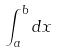Convert formula to latex. <formula><loc_0><loc_0><loc_500><loc_500>\int _ { a } ^ { b } d x</formula> 